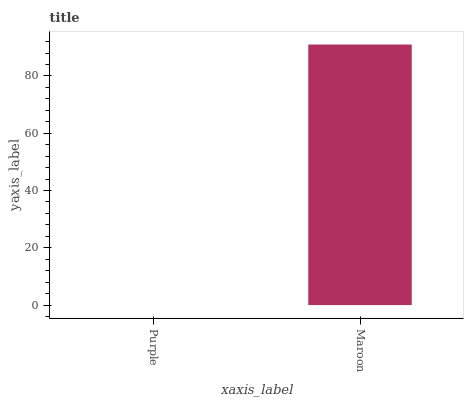Is Purple the minimum?
Answer yes or no. Yes. Is Maroon the maximum?
Answer yes or no. Yes. Is Maroon the minimum?
Answer yes or no. No. Is Maroon greater than Purple?
Answer yes or no. Yes. Is Purple less than Maroon?
Answer yes or no. Yes. Is Purple greater than Maroon?
Answer yes or no. No. Is Maroon less than Purple?
Answer yes or no. No. Is Maroon the high median?
Answer yes or no. Yes. Is Purple the low median?
Answer yes or no. Yes. Is Purple the high median?
Answer yes or no. No. Is Maroon the low median?
Answer yes or no. No. 